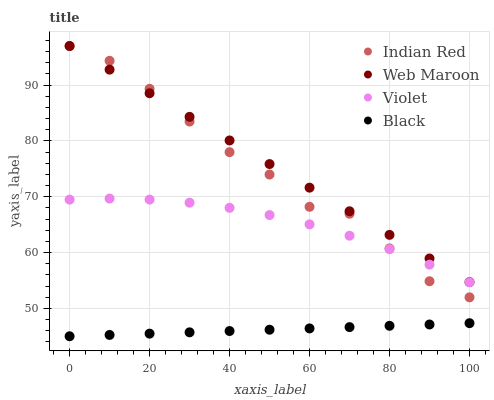Does Black have the minimum area under the curve?
Answer yes or no. Yes. Does Web Maroon have the maximum area under the curve?
Answer yes or no. Yes. Does Indian Red have the minimum area under the curve?
Answer yes or no. No. Does Indian Red have the maximum area under the curve?
Answer yes or no. No. Is Web Maroon the smoothest?
Answer yes or no. Yes. Is Indian Red the roughest?
Answer yes or no. Yes. Is Indian Red the smoothest?
Answer yes or no. No. Is Web Maroon the roughest?
Answer yes or no. No. Does Black have the lowest value?
Answer yes or no. Yes. Does Indian Red have the lowest value?
Answer yes or no. No. Does Indian Red have the highest value?
Answer yes or no. Yes. Does Violet have the highest value?
Answer yes or no. No. Is Black less than Indian Red?
Answer yes or no. Yes. Is Violet greater than Black?
Answer yes or no. Yes. Does Violet intersect Indian Red?
Answer yes or no. Yes. Is Violet less than Indian Red?
Answer yes or no. No. Is Violet greater than Indian Red?
Answer yes or no. No. Does Black intersect Indian Red?
Answer yes or no. No. 